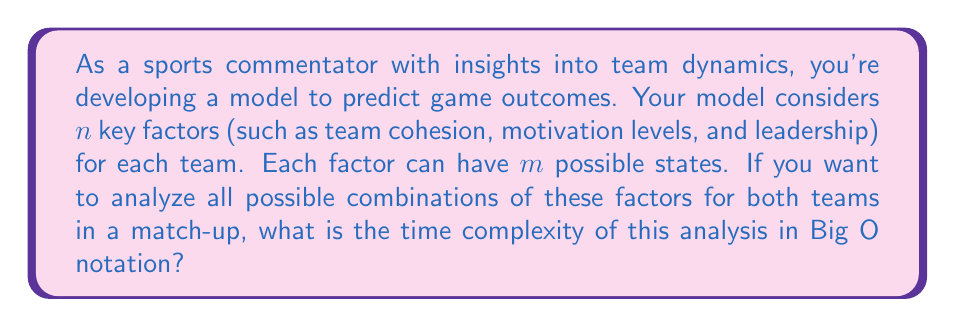Can you answer this question? Let's approach this step-by-step:

1) For each team, we have $n$ factors to consider.

2) Each factor can have $m$ possible states.

3) For one team, the total number of possible combinations is $m^n$, because for each of the $n$ factors, we have $m$ choices.

4) We need to consider this for both teams in a match-up.

5) Therefore, the total number of combinations to analyze is $(m^n)^2 = m^{2n}$.

6) In computational complexity theory, we express this as $O(m^{2n})$.

This is an exponential time complexity, which means that as the number of factors ($n$) or the number of possible states for each factor ($m$) increases, the computational time grows exponentially.

As a former athlete, you can appreciate how this reflects the complexity of real-world team dynamics. Just as the interplay of numerous factors on a team can lead to unpredictable outcomes, the computational complexity of analyzing these factors grows rapidly with each additional consideration.
Answer: $O(m^{2n})$ 